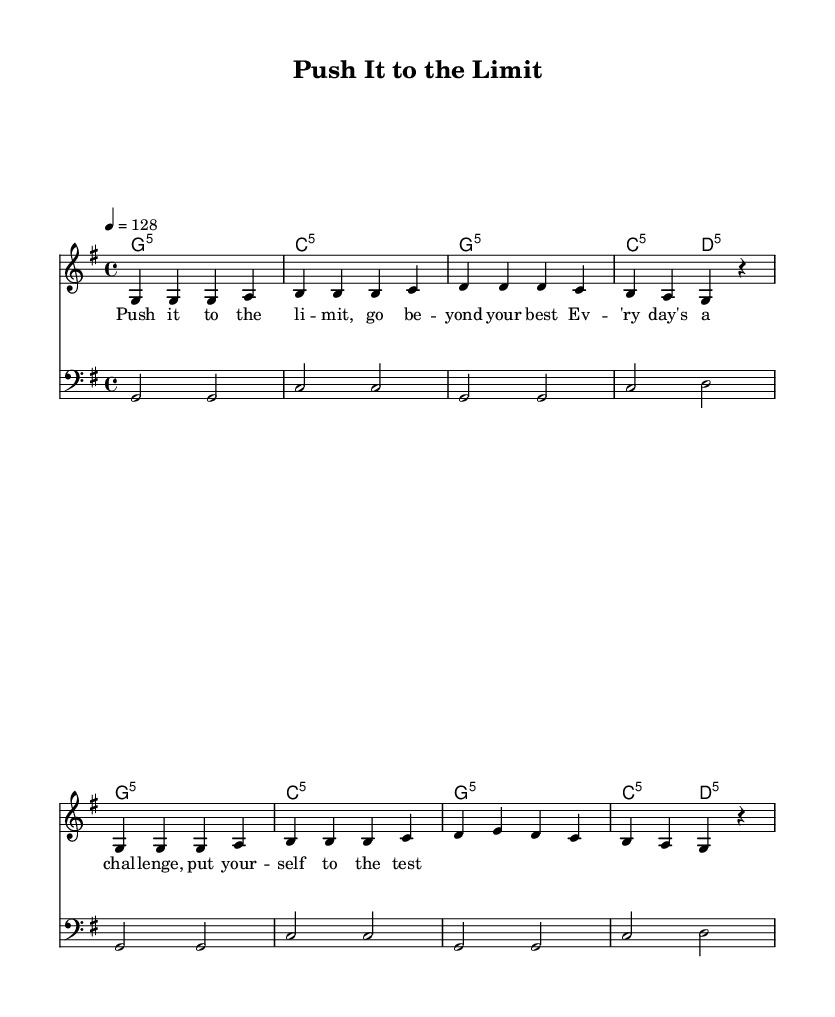What is the key signature of this music? The key signature is G major, which has one sharp (F#). This can be determined by looking at the beginning of the staff where the sharp is indicated.
Answer: G major What is the time signature of this music? The time signature is four-four (4/4), which indicates that there are four beats in each measure and the quarter note gets one beat. This is typically notated at the beginning of the score.
Answer: Four-four What is the tempo marking for this piece? The tempo marking is 128 beats per minute (BPM), as shown in the tempo directive at the start of the music.
Answer: 128 How many measures are there in the melody section? In the melody section, there are eight measures total. Counting the group of notes divided by the vertical lines (bar lines) gives this total.
Answer: Eight What type of chords are used in the harmonies? The harmonies consist of power chords (fifth chords), noted by the use of the notation like g:5 and c:5, indicating root and fifth without the third. This is typical for an upbeat anthem.
Answer: Power chords What lyrical theme does this song convey? The lyrics focus on motivation and pushing oneself to do better, as indicated by the lyrics suggesting challenges and testing oneself, which is common in workout anthems.
Answer: Motivation How does the bass line relate to the melody? The bass line provides a foundational rhythmic and harmonic support that follows the root notes of the chords used in the melody, enhancing the overall energy of the song. The repetitive pattern in bass complements the melodic phrases.
Answer: Harmonically supportive 